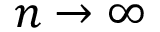<formula> <loc_0><loc_0><loc_500><loc_500>n \to \infty</formula> 